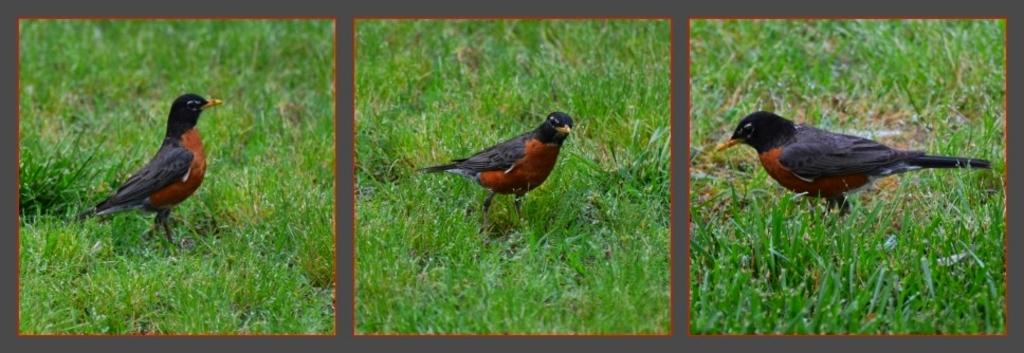What is the main subject of the image? The image contains a collage of photos. What type of natural environment can be seen in some of the photos? Some photos in the collage depict grass. What type of animal can be seen in some of the photos? Some photos in the collage depict a bird. What colors are present in the bird's feathers? The bird's color is black and brown. What type of tin can be seen in the image? There is no tin present in the image; it contains a collage of photos. What type of food is being prepared in the image? There is no food preparation visible in the image; it contains a collage of photos. 